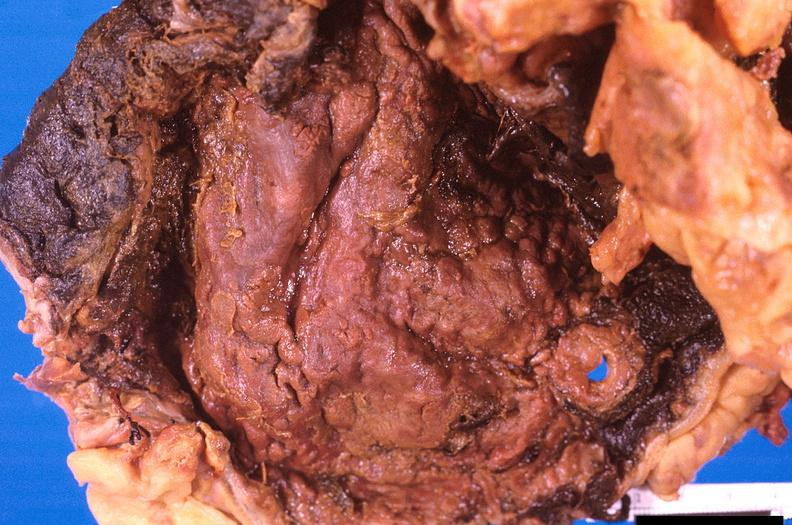where does this belong to?
Answer the question using a single word or phrase. Gastrointestinal system 